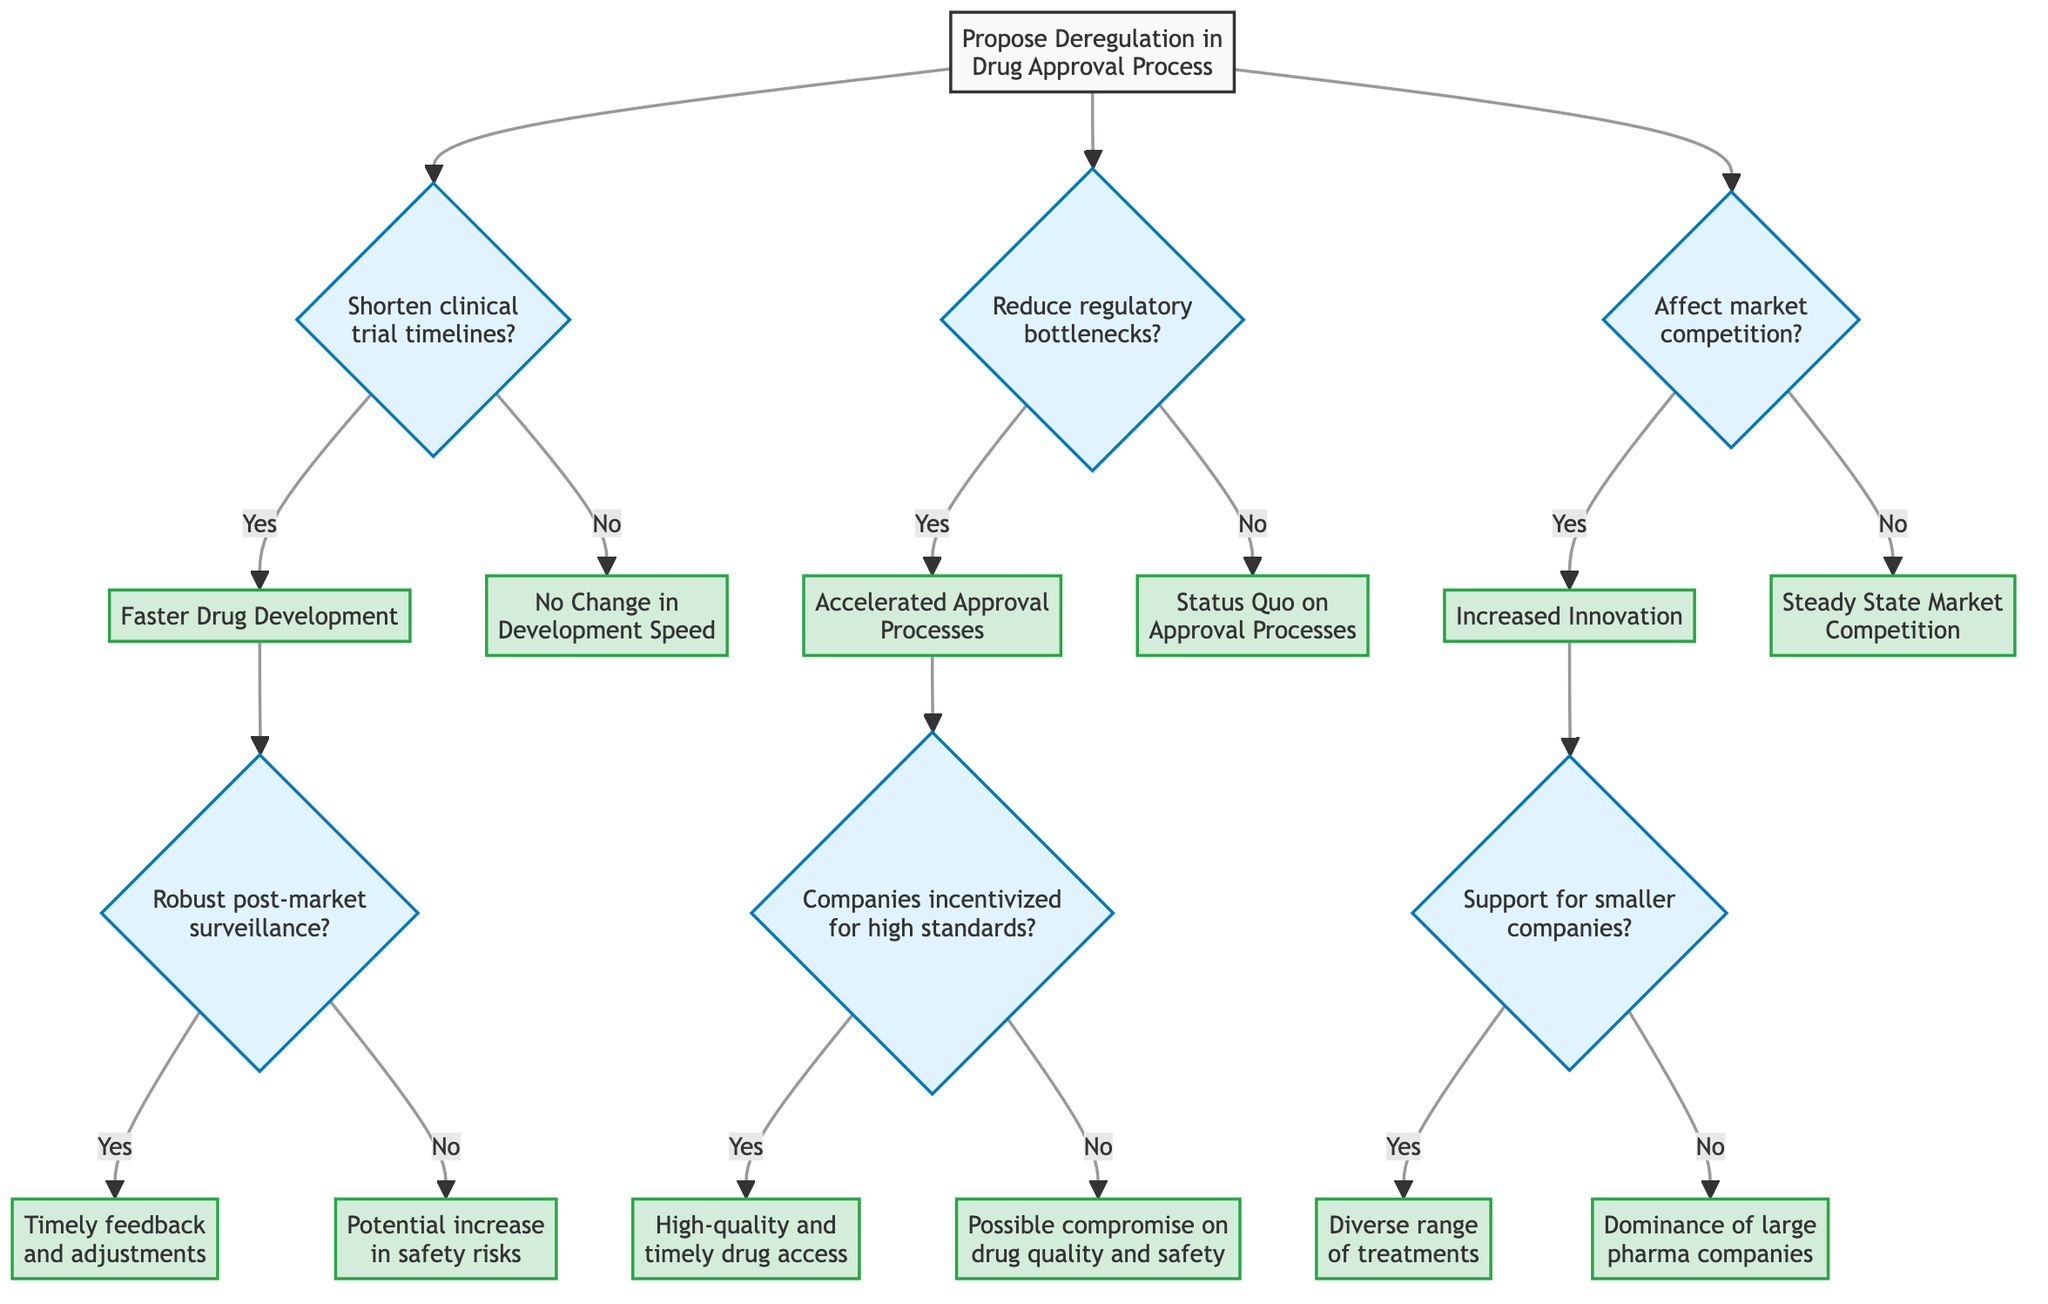What is the starting point of the decision tree? The starting point of the decision tree is "Propose Deregulation in the Drug Approval Process." This is the initial node from which all decisions stem.
Answer: Propose Deregulation in the Drug Approval Process How many major decisions are presented in the diagram? There are three major decisions in the diagram related to shortening clinical trial timelines, reducing regulatory bottlenecks, and affecting market competition. Each of these decisions leads to further outcomes or paths.
Answer: 3 What is the outcome if deregulation shortens clinical trial timelines and there is robust post-market surveillance? If deregulation shortens clinical trial timelines and post-market surveillance is robust, the outcome is "Timely feedback and adjustments," which signifies effective monitoring post-approval.
Answer: Timely feedback and adjustments What happens if deregulation reduces regulatory bottlenecks but companies are not incentivized to maintain high standards? If deregulation reduces regulatory bottlenecks but companies are not incentivized to maintain high safety and efficacy standards, the outcome is "Possible compromise on drug quality and patient safety." This indicates a potential risk if quality is not monitored.
Answer: Possible compromise on drug quality and safety What is the outcome when deregulation affects market competition and there is inadequate support for smaller companies? In this scenario, the outcome is "Dominance of large pharmaceutical companies," which suggests that without support, smaller firms may struggle to compete, letting larger firms take the lead.
Answer: Dominance of large pharma companies If all three decisions (clinical trial timelines, regulatory bottlenecks, and market competition) result positively, what is the overall expected outcome related to drug access? If all three decisions are positive, we would expect outcomes like "Faster Drug Development," "Accelerated Approval Processes," and "Increased Innovation," leading to high-quality drug access and timely treatments.
Answer: High-quality and timely drug access What is the consequence of deregulation not affecting market competition? If deregulation does not affect market competition, the outcome is "Steady State Market Competition," which means that the competitive landscape remains unchanged, potentially affecting innovation and access.
Answer: Steady State Market Competition What can potentially increase safety risks according to the diagram? A potential increase in safety risks is outlined as a consequence if deregulation shortens clinical trial timelines and robust post-market surveillance is not in place. This indicates a risk if post-approval monitoring fails.
Answer: Potential increase in safety risks 